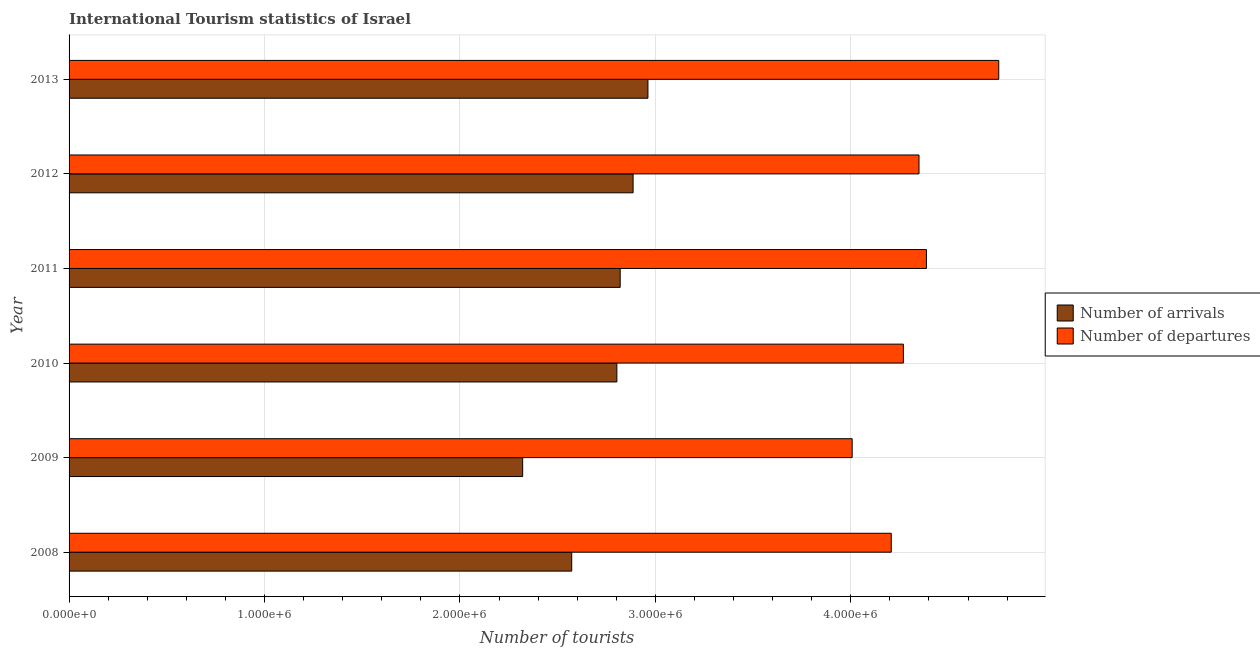How many different coloured bars are there?
Offer a very short reply. 2. Are the number of bars on each tick of the Y-axis equal?
Keep it short and to the point. Yes. What is the label of the 4th group of bars from the top?
Offer a terse response. 2010. What is the number of tourist arrivals in 2012?
Ensure brevity in your answer.  2.89e+06. Across all years, what is the maximum number of tourist departures?
Your response must be concise. 4.76e+06. Across all years, what is the minimum number of tourist departures?
Your response must be concise. 4.01e+06. In which year was the number of tourist departures maximum?
Your answer should be very brief. 2013. In which year was the number of tourist departures minimum?
Provide a short and direct response. 2009. What is the total number of tourist departures in the graph?
Give a very brief answer. 2.60e+07. What is the difference between the number of tourist arrivals in 2009 and that in 2011?
Make the answer very short. -4.99e+05. What is the difference between the number of tourist departures in 2009 and the number of tourist arrivals in 2011?
Offer a very short reply. 1.19e+06. What is the average number of tourist departures per year?
Make the answer very short. 4.33e+06. In the year 2013, what is the difference between the number of tourist departures and number of tourist arrivals?
Make the answer very short. 1.80e+06. In how many years, is the number of tourist arrivals greater than 1000000 ?
Offer a very short reply. 6. What is the ratio of the number of tourist departures in 2009 to that in 2012?
Give a very brief answer. 0.92. What is the difference between the highest and the lowest number of tourist departures?
Ensure brevity in your answer.  7.50e+05. What does the 2nd bar from the top in 2013 represents?
Ensure brevity in your answer.  Number of arrivals. What does the 2nd bar from the bottom in 2012 represents?
Your answer should be compact. Number of departures. What is the difference between two consecutive major ticks on the X-axis?
Make the answer very short. 1.00e+06. Are the values on the major ticks of X-axis written in scientific E-notation?
Offer a terse response. Yes. How many legend labels are there?
Provide a short and direct response. 2. What is the title of the graph?
Your response must be concise. International Tourism statistics of Israel. Does "% of GNI" appear as one of the legend labels in the graph?
Your answer should be compact. No. What is the label or title of the X-axis?
Provide a short and direct response. Number of tourists. What is the Number of tourists of Number of arrivals in 2008?
Offer a terse response. 2.57e+06. What is the Number of tourists of Number of departures in 2008?
Provide a short and direct response. 4.21e+06. What is the Number of tourists of Number of arrivals in 2009?
Offer a terse response. 2.32e+06. What is the Number of tourists in Number of departures in 2009?
Keep it short and to the point. 4.01e+06. What is the Number of tourists in Number of arrivals in 2010?
Your response must be concise. 2.80e+06. What is the Number of tourists in Number of departures in 2010?
Offer a terse response. 4.27e+06. What is the Number of tourists of Number of arrivals in 2011?
Offer a terse response. 2.82e+06. What is the Number of tourists of Number of departures in 2011?
Give a very brief answer. 4.39e+06. What is the Number of tourists in Number of arrivals in 2012?
Your response must be concise. 2.89e+06. What is the Number of tourists of Number of departures in 2012?
Your answer should be compact. 4.35e+06. What is the Number of tourists of Number of arrivals in 2013?
Ensure brevity in your answer.  2.96e+06. What is the Number of tourists of Number of departures in 2013?
Give a very brief answer. 4.76e+06. Across all years, what is the maximum Number of tourists in Number of arrivals?
Keep it short and to the point. 2.96e+06. Across all years, what is the maximum Number of tourists of Number of departures?
Ensure brevity in your answer.  4.76e+06. Across all years, what is the minimum Number of tourists in Number of arrivals?
Offer a terse response. 2.32e+06. Across all years, what is the minimum Number of tourists in Number of departures?
Offer a very short reply. 4.01e+06. What is the total Number of tourists of Number of arrivals in the graph?
Give a very brief answer. 1.64e+07. What is the total Number of tourists in Number of departures in the graph?
Your answer should be very brief. 2.60e+07. What is the difference between the Number of tourists of Number of arrivals in 2008 and that in 2009?
Your answer should be compact. 2.51e+05. What is the difference between the Number of tourists of Number of arrivals in 2008 and that in 2010?
Offer a very short reply. -2.31e+05. What is the difference between the Number of tourists of Number of departures in 2008 and that in 2010?
Keep it short and to the point. -6.20e+04. What is the difference between the Number of tourists of Number of arrivals in 2008 and that in 2011?
Offer a very short reply. -2.48e+05. What is the difference between the Number of tourists of Number of departures in 2008 and that in 2011?
Offer a terse response. -1.80e+05. What is the difference between the Number of tourists in Number of arrivals in 2008 and that in 2012?
Your answer should be very brief. -3.14e+05. What is the difference between the Number of tourists in Number of departures in 2008 and that in 2012?
Offer a very short reply. -1.42e+05. What is the difference between the Number of tourists of Number of arrivals in 2008 and that in 2013?
Make the answer very short. -3.90e+05. What is the difference between the Number of tourists in Number of departures in 2008 and that in 2013?
Provide a succinct answer. -5.50e+05. What is the difference between the Number of tourists in Number of arrivals in 2009 and that in 2010?
Your answer should be compact. -4.82e+05. What is the difference between the Number of tourists of Number of departures in 2009 and that in 2010?
Your answer should be compact. -2.62e+05. What is the difference between the Number of tourists in Number of arrivals in 2009 and that in 2011?
Make the answer very short. -4.99e+05. What is the difference between the Number of tourists in Number of departures in 2009 and that in 2011?
Give a very brief answer. -3.80e+05. What is the difference between the Number of tourists in Number of arrivals in 2009 and that in 2012?
Your response must be concise. -5.65e+05. What is the difference between the Number of tourists of Number of departures in 2009 and that in 2012?
Ensure brevity in your answer.  -3.42e+05. What is the difference between the Number of tourists in Number of arrivals in 2009 and that in 2013?
Keep it short and to the point. -6.41e+05. What is the difference between the Number of tourists in Number of departures in 2009 and that in 2013?
Your answer should be compact. -7.50e+05. What is the difference between the Number of tourists of Number of arrivals in 2010 and that in 2011?
Make the answer very short. -1.70e+04. What is the difference between the Number of tourists in Number of departures in 2010 and that in 2011?
Provide a short and direct response. -1.18e+05. What is the difference between the Number of tourists in Number of arrivals in 2010 and that in 2012?
Offer a very short reply. -8.30e+04. What is the difference between the Number of tourists in Number of arrivals in 2010 and that in 2013?
Provide a short and direct response. -1.59e+05. What is the difference between the Number of tourists of Number of departures in 2010 and that in 2013?
Make the answer very short. -4.88e+05. What is the difference between the Number of tourists of Number of arrivals in 2011 and that in 2012?
Provide a succinct answer. -6.60e+04. What is the difference between the Number of tourists in Number of departures in 2011 and that in 2012?
Your response must be concise. 3.80e+04. What is the difference between the Number of tourists in Number of arrivals in 2011 and that in 2013?
Offer a very short reply. -1.42e+05. What is the difference between the Number of tourists in Number of departures in 2011 and that in 2013?
Provide a succinct answer. -3.70e+05. What is the difference between the Number of tourists in Number of arrivals in 2012 and that in 2013?
Ensure brevity in your answer.  -7.60e+04. What is the difference between the Number of tourists of Number of departures in 2012 and that in 2013?
Make the answer very short. -4.08e+05. What is the difference between the Number of tourists of Number of arrivals in 2008 and the Number of tourists of Number of departures in 2009?
Offer a very short reply. -1.44e+06. What is the difference between the Number of tourists of Number of arrivals in 2008 and the Number of tourists of Number of departures in 2010?
Offer a terse response. -1.70e+06. What is the difference between the Number of tourists in Number of arrivals in 2008 and the Number of tourists in Number of departures in 2011?
Your response must be concise. -1.82e+06. What is the difference between the Number of tourists of Number of arrivals in 2008 and the Number of tourists of Number of departures in 2012?
Your answer should be compact. -1.78e+06. What is the difference between the Number of tourists in Number of arrivals in 2008 and the Number of tourists in Number of departures in 2013?
Provide a succinct answer. -2.18e+06. What is the difference between the Number of tourists of Number of arrivals in 2009 and the Number of tourists of Number of departures in 2010?
Ensure brevity in your answer.  -1.95e+06. What is the difference between the Number of tourists of Number of arrivals in 2009 and the Number of tourists of Number of departures in 2011?
Provide a short and direct response. -2.07e+06. What is the difference between the Number of tourists of Number of arrivals in 2009 and the Number of tourists of Number of departures in 2012?
Ensure brevity in your answer.  -2.03e+06. What is the difference between the Number of tourists of Number of arrivals in 2009 and the Number of tourists of Number of departures in 2013?
Ensure brevity in your answer.  -2.44e+06. What is the difference between the Number of tourists in Number of arrivals in 2010 and the Number of tourists in Number of departures in 2011?
Your response must be concise. -1.58e+06. What is the difference between the Number of tourists in Number of arrivals in 2010 and the Number of tourists in Number of departures in 2012?
Your answer should be compact. -1.55e+06. What is the difference between the Number of tourists in Number of arrivals in 2010 and the Number of tourists in Number of departures in 2013?
Offer a terse response. -1.95e+06. What is the difference between the Number of tourists of Number of arrivals in 2011 and the Number of tourists of Number of departures in 2012?
Offer a very short reply. -1.53e+06. What is the difference between the Number of tourists of Number of arrivals in 2011 and the Number of tourists of Number of departures in 2013?
Provide a succinct answer. -1.94e+06. What is the difference between the Number of tourists in Number of arrivals in 2012 and the Number of tourists in Number of departures in 2013?
Ensure brevity in your answer.  -1.87e+06. What is the average Number of tourists of Number of arrivals per year?
Provide a short and direct response. 2.73e+06. What is the average Number of tourists of Number of departures per year?
Your response must be concise. 4.33e+06. In the year 2008, what is the difference between the Number of tourists of Number of arrivals and Number of tourists of Number of departures?
Ensure brevity in your answer.  -1.64e+06. In the year 2009, what is the difference between the Number of tourists in Number of arrivals and Number of tourists in Number of departures?
Ensure brevity in your answer.  -1.69e+06. In the year 2010, what is the difference between the Number of tourists in Number of arrivals and Number of tourists in Number of departures?
Give a very brief answer. -1.47e+06. In the year 2011, what is the difference between the Number of tourists in Number of arrivals and Number of tourists in Number of departures?
Keep it short and to the point. -1.57e+06. In the year 2012, what is the difference between the Number of tourists in Number of arrivals and Number of tourists in Number of departures?
Your answer should be compact. -1.46e+06. In the year 2013, what is the difference between the Number of tourists in Number of arrivals and Number of tourists in Number of departures?
Offer a terse response. -1.80e+06. What is the ratio of the Number of tourists of Number of arrivals in 2008 to that in 2009?
Your answer should be very brief. 1.11. What is the ratio of the Number of tourists in Number of departures in 2008 to that in 2009?
Give a very brief answer. 1.05. What is the ratio of the Number of tourists in Number of arrivals in 2008 to that in 2010?
Your response must be concise. 0.92. What is the ratio of the Number of tourists in Number of departures in 2008 to that in 2010?
Provide a succinct answer. 0.99. What is the ratio of the Number of tourists of Number of arrivals in 2008 to that in 2011?
Ensure brevity in your answer.  0.91. What is the ratio of the Number of tourists in Number of arrivals in 2008 to that in 2012?
Give a very brief answer. 0.89. What is the ratio of the Number of tourists in Number of departures in 2008 to that in 2012?
Your answer should be compact. 0.97. What is the ratio of the Number of tourists in Number of arrivals in 2008 to that in 2013?
Ensure brevity in your answer.  0.87. What is the ratio of the Number of tourists in Number of departures in 2008 to that in 2013?
Keep it short and to the point. 0.88. What is the ratio of the Number of tourists of Number of arrivals in 2009 to that in 2010?
Your answer should be very brief. 0.83. What is the ratio of the Number of tourists in Number of departures in 2009 to that in 2010?
Your response must be concise. 0.94. What is the ratio of the Number of tourists in Number of arrivals in 2009 to that in 2011?
Make the answer very short. 0.82. What is the ratio of the Number of tourists in Number of departures in 2009 to that in 2011?
Your answer should be compact. 0.91. What is the ratio of the Number of tourists in Number of arrivals in 2009 to that in 2012?
Keep it short and to the point. 0.8. What is the ratio of the Number of tourists of Number of departures in 2009 to that in 2012?
Offer a very short reply. 0.92. What is the ratio of the Number of tourists of Number of arrivals in 2009 to that in 2013?
Your answer should be very brief. 0.78. What is the ratio of the Number of tourists in Number of departures in 2009 to that in 2013?
Make the answer very short. 0.84. What is the ratio of the Number of tourists in Number of arrivals in 2010 to that in 2011?
Give a very brief answer. 0.99. What is the ratio of the Number of tourists of Number of departures in 2010 to that in 2011?
Your answer should be compact. 0.97. What is the ratio of the Number of tourists of Number of arrivals in 2010 to that in 2012?
Provide a succinct answer. 0.97. What is the ratio of the Number of tourists in Number of departures in 2010 to that in 2012?
Ensure brevity in your answer.  0.98. What is the ratio of the Number of tourists of Number of arrivals in 2010 to that in 2013?
Give a very brief answer. 0.95. What is the ratio of the Number of tourists of Number of departures in 2010 to that in 2013?
Keep it short and to the point. 0.9. What is the ratio of the Number of tourists in Number of arrivals in 2011 to that in 2012?
Your response must be concise. 0.98. What is the ratio of the Number of tourists of Number of departures in 2011 to that in 2012?
Your response must be concise. 1.01. What is the ratio of the Number of tourists in Number of arrivals in 2011 to that in 2013?
Offer a very short reply. 0.95. What is the ratio of the Number of tourists of Number of departures in 2011 to that in 2013?
Provide a short and direct response. 0.92. What is the ratio of the Number of tourists in Number of arrivals in 2012 to that in 2013?
Your answer should be very brief. 0.97. What is the ratio of the Number of tourists of Number of departures in 2012 to that in 2013?
Your answer should be very brief. 0.91. What is the difference between the highest and the second highest Number of tourists of Number of arrivals?
Your answer should be compact. 7.60e+04. What is the difference between the highest and the second highest Number of tourists in Number of departures?
Give a very brief answer. 3.70e+05. What is the difference between the highest and the lowest Number of tourists of Number of arrivals?
Your response must be concise. 6.41e+05. What is the difference between the highest and the lowest Number of tourists of Number of departures?
Give a very brief answer. 7.50e+05. 